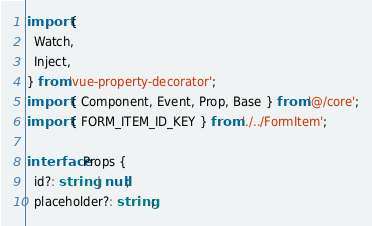<code> <loc_0><loc_0><loc_500><loc_500><_TypeScript_>import {
  Watch,
  Inject,
} from 'vue-property-decorator';
import { Component, Event, Prop, Base } from '@/core';
import { FORM_ITEM_ID_KEY } from './../FormItem';

interface Props {
  id?: string | null;
  placeholder?: string;</code> 